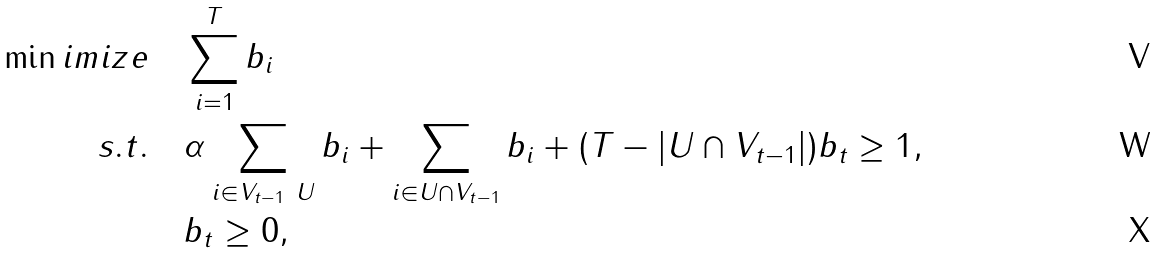Convert formula to latex. <formula><loc_0><loc_0><loc_500><loc_500>\min i m i z e \quad & \sum _ { i = 1 } ^ { T } b _ { i } \\ s . t . \quad & \alpha \sum _ { i \in V _ { t - 1 } \ U } b _ { i } + \sum _ { i \in U \cap V _ { t - 1 } } b _ { i } + ( T - | U \cap V _ { t - 1 } | ) b _ { t } \geq 1 , \\ & b _ { t } \geq 0 ,</formula> 